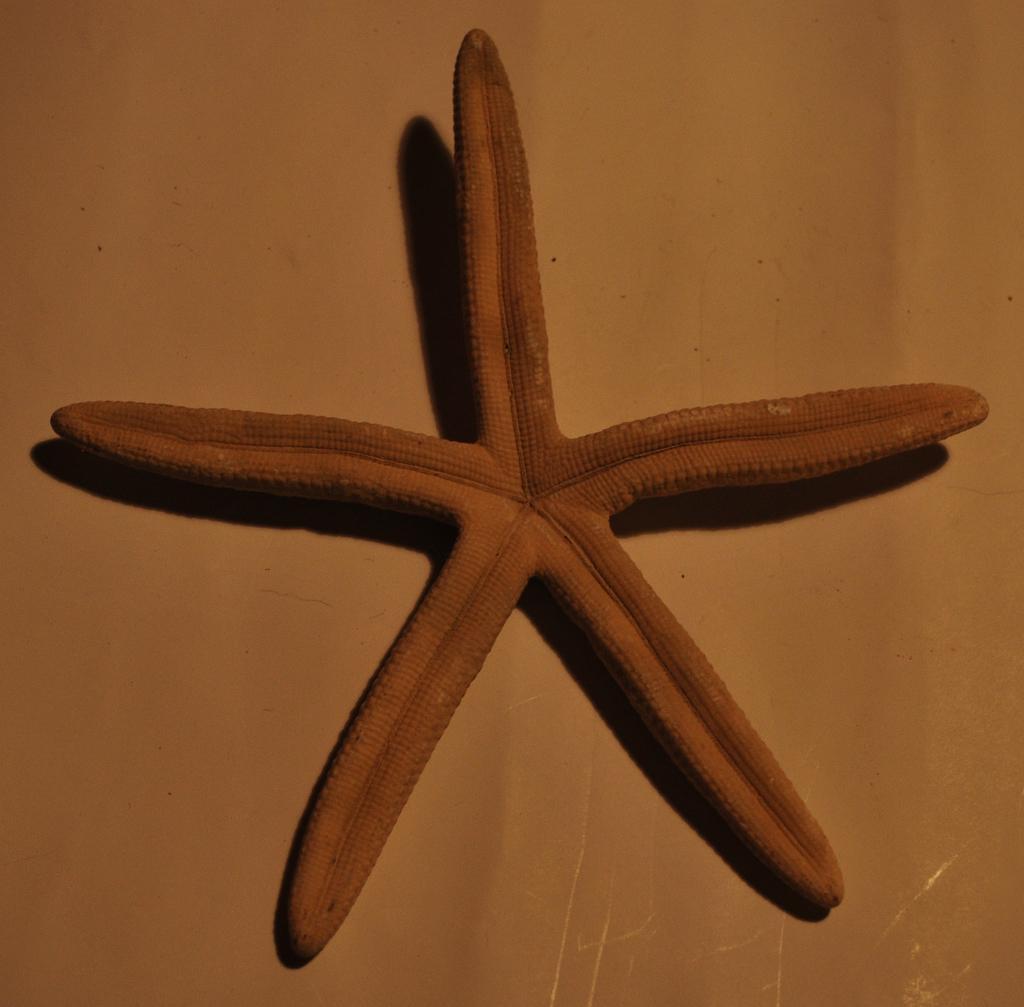Describe this image in one or two sentences. In this image we can see a starfish. 